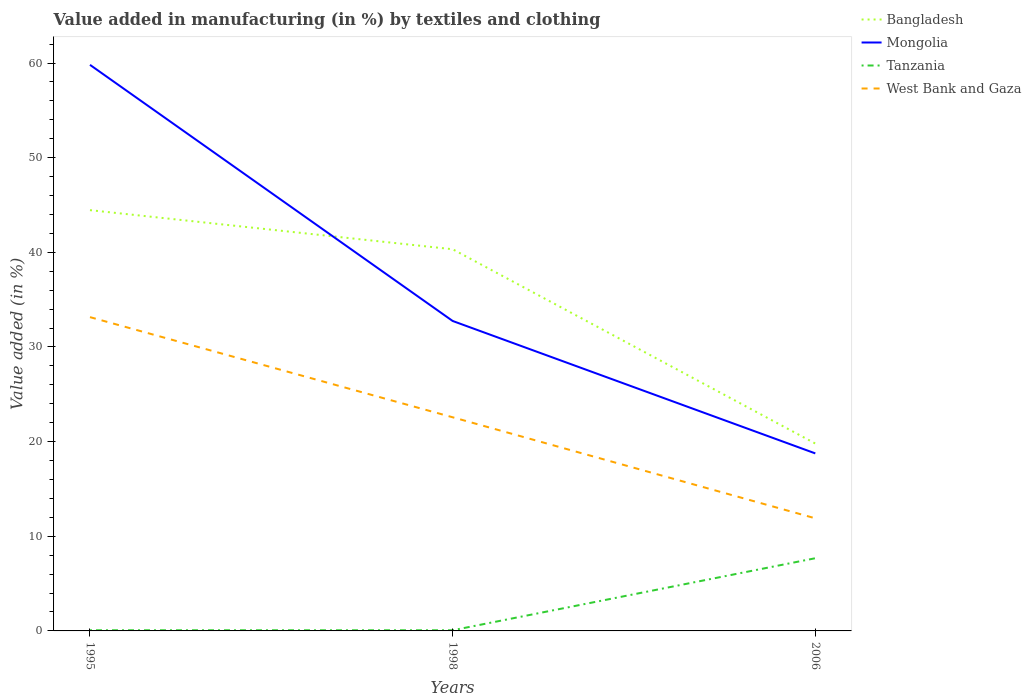How many different coloured lines are there?
Ensure brevity in your answer.  4. Across all years, what is the maximum percentage of value added in manufacturing by textiles and clothing in Tanzania?
Provide a succinct answer. 0.07. What is the total percentage of value added in manufacturing by textiles and clothing in Mongolia in the graph?
Your answer should be very brief. 27.06. What is the difference between the highest and the second highest percentage of value added in manufacturing by textiles and clothing in Tanzania?
Your answer should be compact. 7.61. How many lines are there?
Ensure brevity in your answer.  4. How many years are there in the graph?
Make the answer very short. 3. Does the graph contain any zero values?
Make the answer very short. No. Where does the legend appear in the graph?
Ensure brevity in your answer.  Top right. How are the legend labels stacked?
Give a very brief answer. Vertical. What is the title of the graph?
Ensure brevity in your answer.  Value added in manufacturing (in %) by textiles and clothing. What is the label or title of the Y-axis?
Offer a terse response. Value added (in %). What is the Value added (in %) of Bangladesh in 1995?
Offer a very short reply. 44.46. What is the Value added (in %) of Mongolia in 1995?
Your answer should be compact. 59.81. What is the Value added (in %) of Tanzania in 1995?
Keep it short and to the point. 0.07. What is the Value added (in %) in West Bank and Gaza in 1995?
Provide a succinct answer. 33.15. What is the Value added (in %) of Bangladesh in 1998?
Provide a succinct answer. 40.32. What is the Value added (in %) of Mongolia in 1998?
Your response must be concise. 32.75. What is the Value added (in %) in Tanzania in 1998?
Ensure brevity in your answer.  0.07. What is the Value added (in %) in West Bank and Gaza in 1998?
Offer a very short reply. 22.57. What is the Value added (in %) in Bangladesh in 2006?
Give a very brief answer. 19.8. What is the Value added (in %) of Mongolia in 2006?
Give a very brief answer. 18.76. What is the Value added (in %) in Tanzania in 2006?
Offer a terse response. 7.68. What is the Value added (in %) of West Bank and Gaza in 2006?
Give a very brief answer. 11.9. Across all years, what is the maximum Value added (in %) in Bangladesh?
Make the answer very short. 44.46. Across all years, what is the maximum Value added (in %) of Mongolia?
Provide a succinct answer. 59.81. Across all years, what is the maximum Value added (in %) of Tanzania?
Offer a very short reply. 7.68. Across all years, what is the maximum Value added (in %) in West Bank and Gaza?
Make the answer very short. 33.15. Across all years, what is the minimum Value added (in %) of Bangladesh?
Offer a terse response. 19.8. Across all years, what is the minimum Value added (in %) in Mongolia?
Offer a terse response. 18.76. Across all years, what is the minimum Value added (in %) of Tanzania?
Provide a short and direct response. 0.07. Across all years, what is the minimum Value added (in %) in West Bank and Gaza?
Your answer should be very brief. 11.9. What is the total Value added (in %) in Bangladesh in the graph?
Your answer should be very brief. 104.58. What is the total Value added (in %) of Mongolia in the graph?
Your answer should be compact. 111.31. What is the total Value added (in %) in Tanzania in the graph?
Your answer should be compact. 7.82. What is the total Value added (in %) of West Bank and Gaza in the graph?
Your answer should be very brief. 67.62. What is the difference between the Value added (in %) of Bangladesh in 1995 and that in 1998?
Your answer should be compact. 4.13. What is the difference between the Value added (in %) of Mongolia in 1995 and that in 1998?
Provide a succinct answer. 27.06. What is the difference between the Value added (in %) in Tanzania in 1995 and that in 1998?
Your answer should be compact. 0. What is the difference between the Value added (in %) in West Bank and Gaza in 1995 and that in 1998?
Provide a succinct answer. 10.58. What is the difference between the Value added (in %) in Bangladesh in 1995 and that in 2006?
Make the answer very short. 24.66. What is the difference between the Value added (in %) in Mongolia in 1995 and that in 2006?
Make the answer very short. 41.05. What is the difference between the Value added (in %) of Tanzania in 1995 and that in 2006?
Provide a succinct answer. -7.61. What is the difference between the Value added (in %) in West Bank and Gaza in 1995 and that in 2006?
Keep it short and to the point. 21.26. What is the difference between the Value added (in %) of Bangladesh in 1998 and that in 2006?
Offer a very short reply. 20.53. What is the difference between the Value added (in %) of Mongolia in 1998 and that in 2006?
Your answer should be very brief. 13.99. What is the difference between the Value added (in %) in Tanzania in 1998 and that in 2006?
Provide a short and direct response. -7.61. What is the difference between the Value added (in %) of West Bank and Gaza in 1998 and that in 2006?
Provide a short and direct response. 10.68. What is the difference between the Value added (in %) of Bangladesh in 1995 and the Value added (in %) of Mongolia in 1998?
Provide a succinct answer. 11.71. What is the difference between the Value added (in %) in Bangladesh in 1995 and the Value added (in %) in Tanzania in 1998?
Your answer should be compact. 44.39. What is the difference between the Value added (in %) in Bangladesh in 1995 and the Value added (in %) in West Bank and Gaza in 1998?
Provide a short and direct response. 21.88. What is the difference between the Value added (in %) of Mongolia in 1995 and the Value added (in %) of Tanzania in 1998?
Give a very brief answer. 59.74. What is the difference between the Value added (in %) of Mongolia in 1995 and the Value added (in %) of West Bank and Gaza in 1998?
Provide a succinct answer. 37.23. What is the difference between the Value added (in %) in Tanzania in 1995 and the Value added (in %) in West Bank and Gaza in 1998?
Provide a succinct answer. -22.5. What is the difference between the Value added (in %) in Bangladesh in 1995 and the Value added (in %) in Mongolia in 2006?
Give a very brief answer. 25.7. What is the difference between the Value added (in %) in Bangladesh in 1995 and the Value added (in %) in Tanzania in 2006?
Offer a terse response. 36.78. What is the difference between the Value added (in %) of Bangladesh in 1995 and the Value added (in %) of West Bank and Gaza in 2006?
Keep it short and to the point. 32.56. What is the difference between the Value added (in %) of Mongolia in 1995 and the Value added (in %) of Tanzania in 2006?
Offer a terse response. 52.13. What is the difference between the Value added (in %) in Mongolia in 1995 and the Value added (in %) in West Bank and Gaza in 2006?
Ensure brevity in your answer.  47.91. What is the difference between the Value added (in %) in Tanzania in 1995 and the Value added (in %) in West Bank and Gaza in 2006?
Provide a short and direct response. -11.83. What is the difference between the Value added (in %) in Bangladesh in 1998 and the Value added (in %) in Mongolia in 2006?
Your response must be concise. 21.57. What is the difference between the Value added (in %) in Bangladesh in 1998 and the Value added (in %) in Tanzania in 2006?
Make the answer very short. 32.64. What is the difference between the Value added (in %) in Bangladesh in 1998 and the Value added (in %) in West Bank and Gaza in 2006?
Keep it short and to the point. 28.43. What is the difference between the Value added (in %) in Mongolia in 1998 and the Value added (in %) in Tanzania in 2006?
Provide a short and direct response. 25.07. What is the difference between the Value added (in %) of Mongolia in 1998 and the Value added (in %) of West Bank and Gaza in 2006?
Your answer should be compact. 20.85. What is the difference between the Value added (in %) in Tanzania in 1998 and the Value added (in %) in West Bank and Gaza in 2006?
Keep it short and to the point. -11.83. What is the average Value added (in %) in Bangladesh per year?
Offer a very short reply. 34.86. What is the average Value added (in %) in Mongolia per year?
Your answer should be compact. 37.1. What is the average Value added (in %) in Tanzania per year?
Make the answer very short. 2.61. What is the average Value added (in %) in West Bank and Gaza per year?
Give a very brief answer. 22.54. In the year 1995, what is the difference between the Value added (in %) of Bangladesh and Value added (in %) of Mongolia?
Your answer should be compact. -15.35. In the year 1995, what is the difference between the Value added (in %) in Bangladesh and Value added (in %) in Tanzania?
Your answer should be compact. 44.38. In the year 1995, what is the difference between the Value added (in %) of Bangladesh and Value added (in %) of West Bank and Gaza?
Offer a very short reply. 11.3. In the year 1995, what is the difference between the Value added (in %) of Mongolia and Value added (in %) of Tanzania?
Offer a terse response. 59.74. In the year 1995, what is the difference between the Value added (in %) of Mongolia and Value added (in %) of West Bank and Gaza?
Provide a short and direct response. 26.65. In the year 1995, what is the difference between the Value added (in %) in Tanzania and Value added (in %) in West Bank and Gaza?
Keep it short and to the point. -33.08. In the year 1998, what is the difference between the Value added (in %) of Bangladesh and Value added (in %) of Mongolia?
Provide a short and direct response. 7.58. In the year 1998, what is the difference between the Value added (in %) of Bangladesh and Value added (in %) of Tanzania?
Your answer should be compact. 40.26. In the year 1998, what is the difference between the Value added (in %) of Bangladesh and Value added (in %) of West Bank and Gaza?
Offer a terse response. 17.75. In the year 1998, what is the difference between the Value added (in %) of Mongolia and Value added (in %) of Tanzania?
Provide a succinct answer. 32.68. In the year 1998, what is the difference between the Value added (in %) in Mongolia and Value added (in %) in West Bank and Gaza?
Ensure brevity in your answer.  10.18. In the year 1998, what is the difference between the Value added (in %) of Tanzania and Value added (in %) of West Bank and Gaza?
Ensure brevity in your answer.  -22.5. In the year 2006, what is the difference between the Value added (in %) of Bangladesh and Value added (in %) of Mongolia?
Your response must be concise. 1.04. In the year 2006, what is the difference between the Value added (in %) of Bangladesh and Value added (in %) of Tanzania?
Ensure brevity in your answer.  12.12. In the year 2006, what is the difference between the Value added (in %) in Bangladesh and Value added (in %) in West Bank and Gaza?
Provide a short and direct response. 7.9. In the year 2006, what is the difference between the Value added (in %) of Mongolia and Value added (in %) of Tanzania?
Provide a short and direct response. 11.07. In the year 2006, what is the difference between the Value added (in %) of Mongolia and Value added (in %) of West Bank and Gaza?
Give a very brief answer. 6.86. In the year 2006, what is the difference between the Value added (in %) in Tanzania and Value added (in %) in West Bank and Gaza?
Ensure brevity in your answer.  -4.22. What is the ratio of the Value added (in %) of Bangladesh in 1995 to that in 1998?
Give a very brief answer. 1.1. What is the ratio of the Value added (in %) in Mongolia in 1995 to that in 1998?
Provide a succinct answer. 1.83. What is the ratio of the Value added (in %) of Tanzania in 1995 to that in 1998?
Your answer should be compact. 1.02. What is the ratio of the Value added (in %) of West Bank and Gaza in 1995 to that in 1998?
Provide a short and direct response. 1.47. What is the ratio of the Value added (in %) in Bangladesh in 1995 to that in 2006?
Offer a terse response. 2.25. What is the ratio of the Value added (in %) of Mongolia in 1995 to that in 2006?
Give a very brief answer. 3.19. What is the ratio of the Value added (in %) of Tanzania in 1995 to that in 2006?
Offer a very short reply. 0.01. What is the ratio of the Value added (in %) in West Bank and Gaza in 1995 to that in 2006?
Give a very brief answer. 2.79. What is the ratio of the Value added (in %) of Bangladesh in 1998 to that in 2006?
Your answer should be very brief. 2.04. What is the ratio of the Value added (in %) of Mongolia in 1998 to that in 2006?
Provide a succinct answer. 1.75. What is the ratio of the Value added (in %) in Tanzania in 1998 to that in 2006?
Offer a terse response. 0.01. What is the ratio of the Value added (in %) of West Bank and Gaza in 1998 to that in 2006?
Offer a very short reply. 1.9. What is the difference between the highest and the second highest Value added (in %) in Bangladesh?
Make the answer very short. 4.13. What is the difference between the highest and the second highest Value added (in %) in Mongolia?
Ensure brevity in your answer.  27.06. What is the difference between the highest and the second highest Value added (in %) of Tanzania?
Ensure brevity in your answer.  7.61. What is the difference between the highest and the second highest Value added (in %) in West Bank and Gaza?
Offer a terse response. 10.58. What is the difference between the highest and the lowest Value added (in %) in Bangladesh?
Your answer should be compact. 24.66. What is the difference between the highest and the lowest Value added (in %) of Mongolia?
Offer a very short reply. 41.05. What is the difference between the highest and the lowest Value added (in %) of Tanzania?
Offer a very short reply. 7.61. What is the difference between the highest and the lowest Value added (in %) of West Bank and Gaza?
Your answer should be compact. 21.26. 